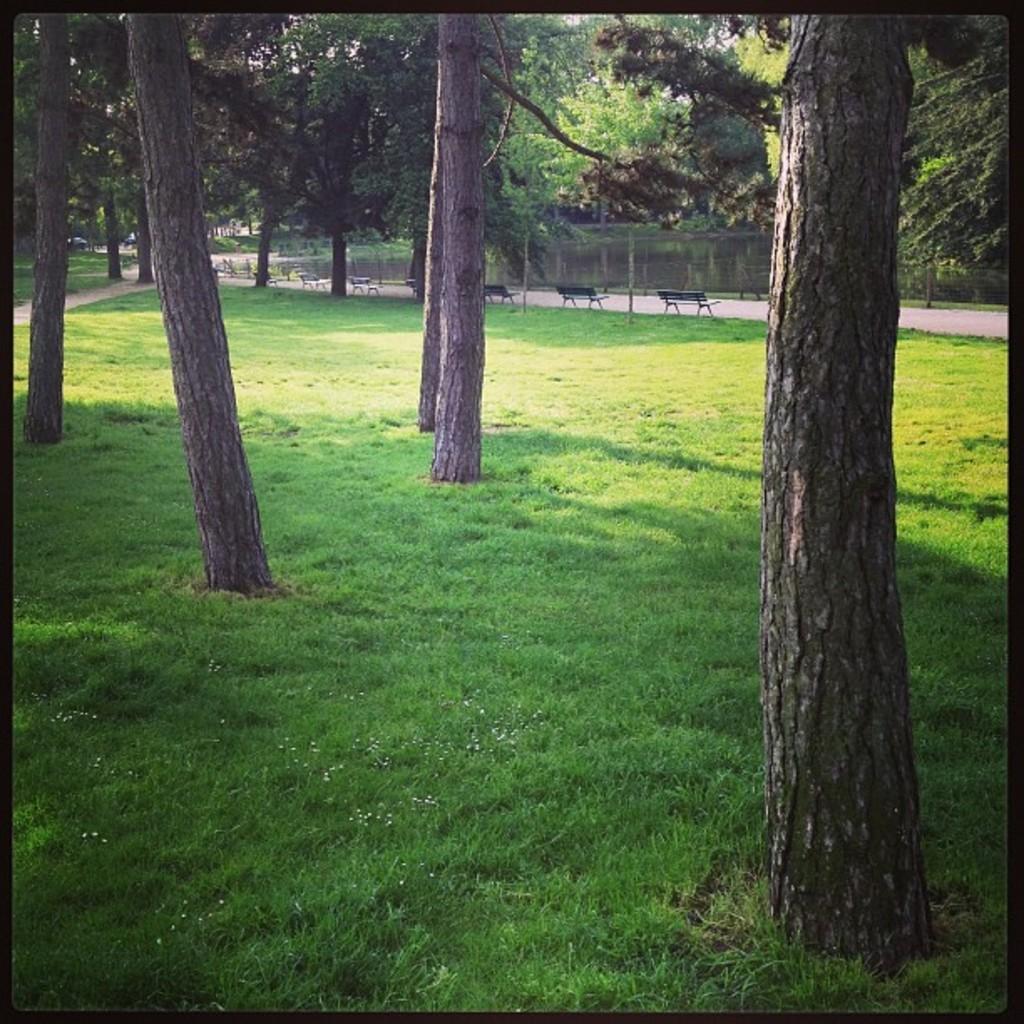In one or two sentences, can you explain what this image depicts? In the foreground of this image, there is grass and trees. In the background, there are benches, trees, fencing and the water. 